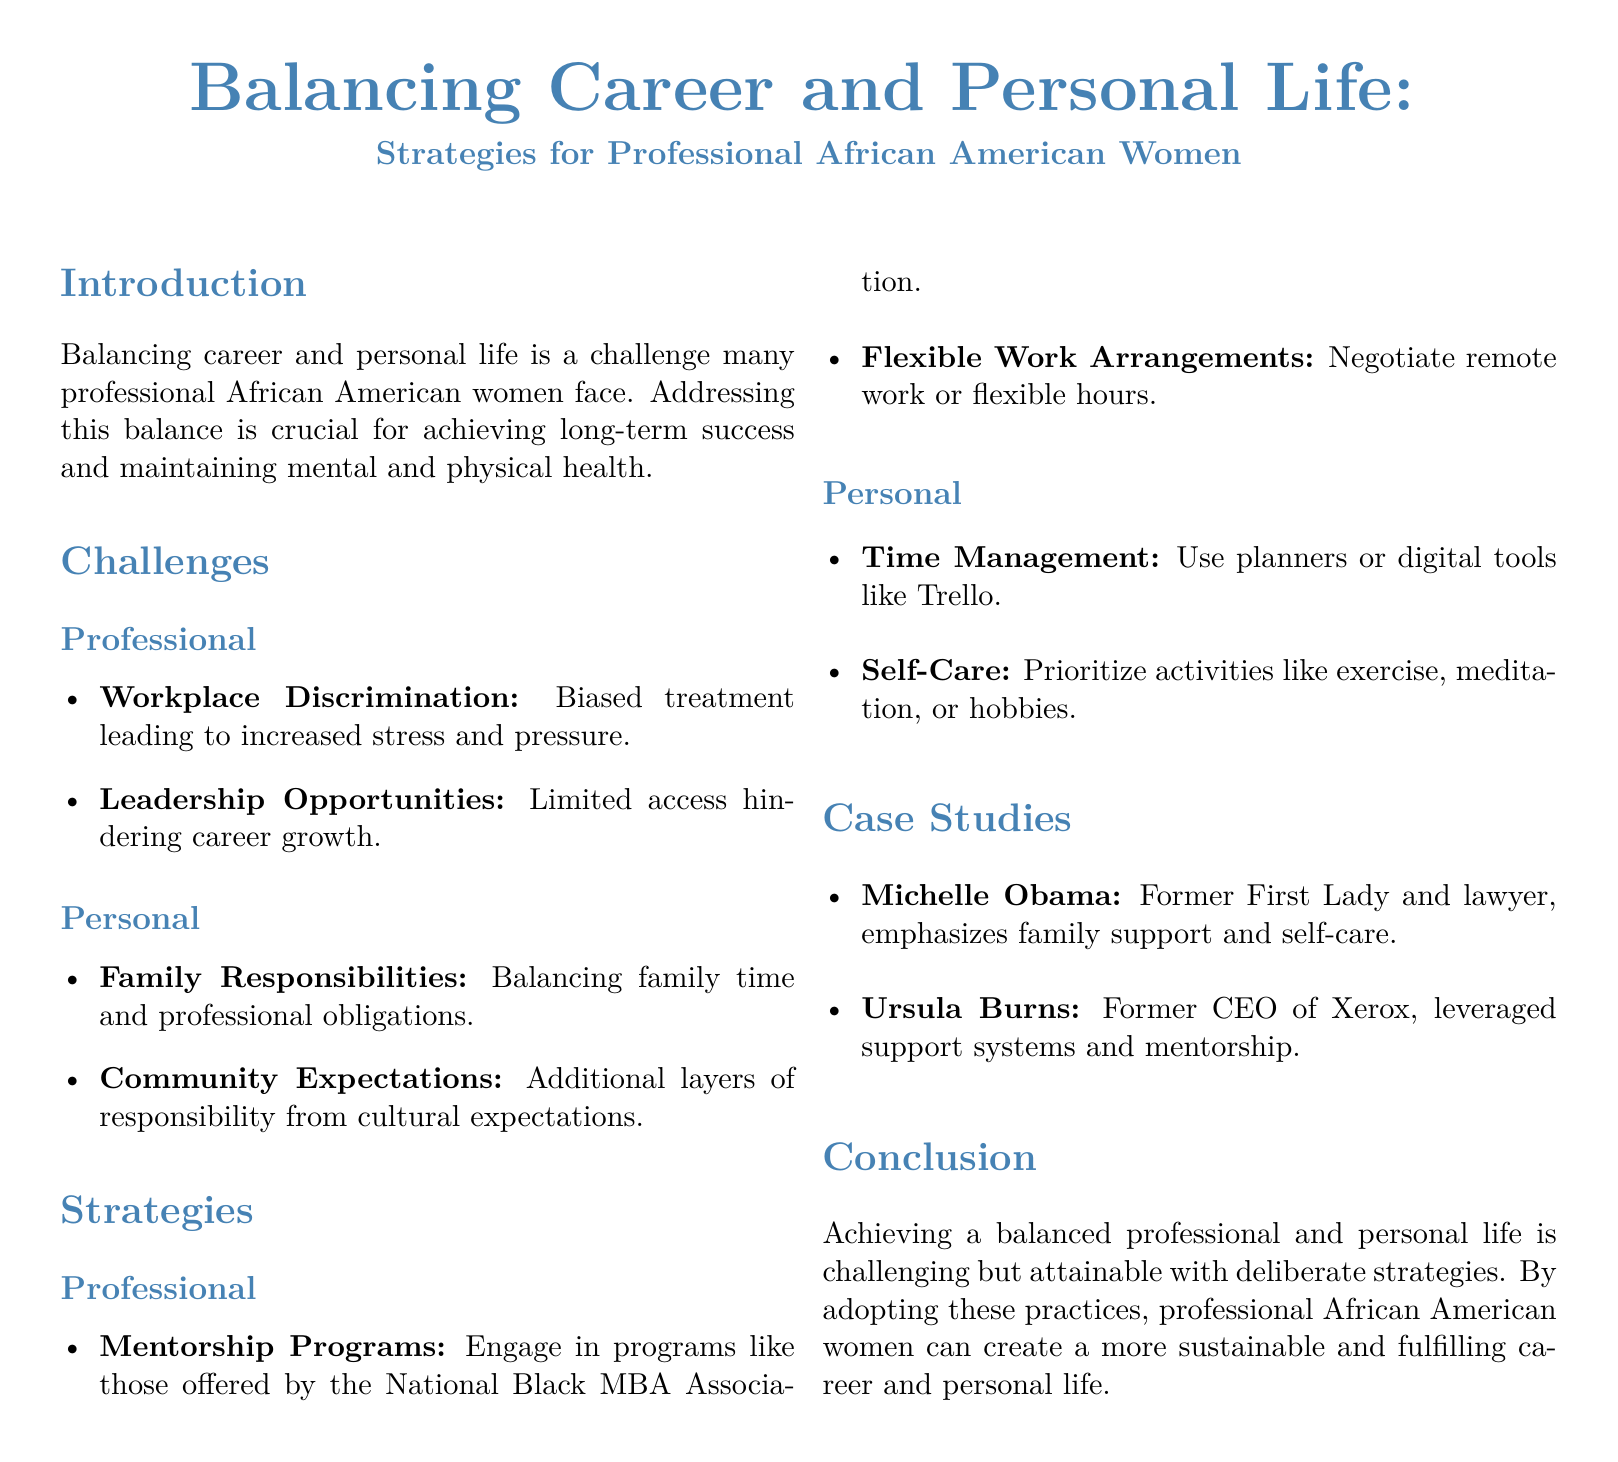What are two challenges faced by professional African American women? The document lists challenges under professional and personal categories, specifically mentioning workplace discrimination and family responsibilities.
Answer: Workplace discrimination, family responsibilities What is one professional strategy suggested in the document? The document provides strategies including mentorship programs and flexible work arrangements as professional strategies.
Answer: Mentorship programs Who is mentioned as a case study in the document? The document lists Michelle Obama and Ursula Burns as examples of successful individuals who exemplify the strategies discussed.
Answer: Michelle Obama What is the main focus of the whitepaper? The document emphasizes the importance of balancing career and personal life for professional African American women, detailing challenges and strategies.
Answer: Balancing career and personal life What tool is recommended for time management? The document suggests using planners or digital tools for effective time management as part of personal strategies.
Answer: Trello How many sections are included in the strategies part? The strategies section is divided into professional and personal, making a total of two subsections under that category.
Answer: Two Which community organization is mentioned in relation to mentorship? The document mentions the National Black MBA Association as a source for mentorship programs.
Answer: National Black MBA Association 